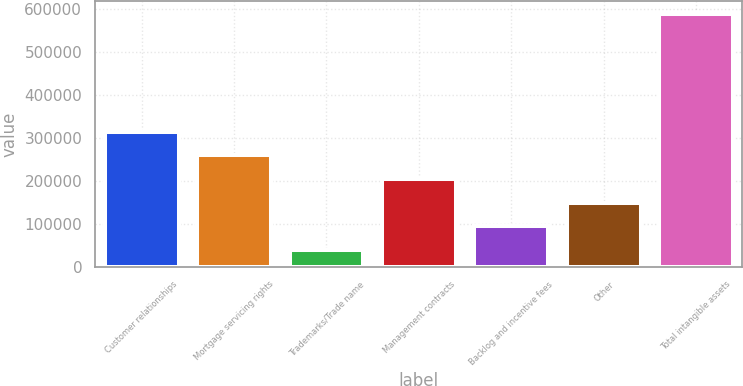Convert chart to OTSL. <chart><loc_0><loc_0><loc_500><loc_500><bar_chart><fcel>Customer relationships<fcel>Mortgage servicing rights<fcel>Trademarks/Trade name<fcel>Management contracts<fcel>Backlog and incentive fees<fcel>Other<fcel>Total intangible assets<nl><fcel>313908<fcel>258843<fcel>38581<fcel>203778<fcel>93646.5<fcel>148712<fcel>589236<nl></chart> 